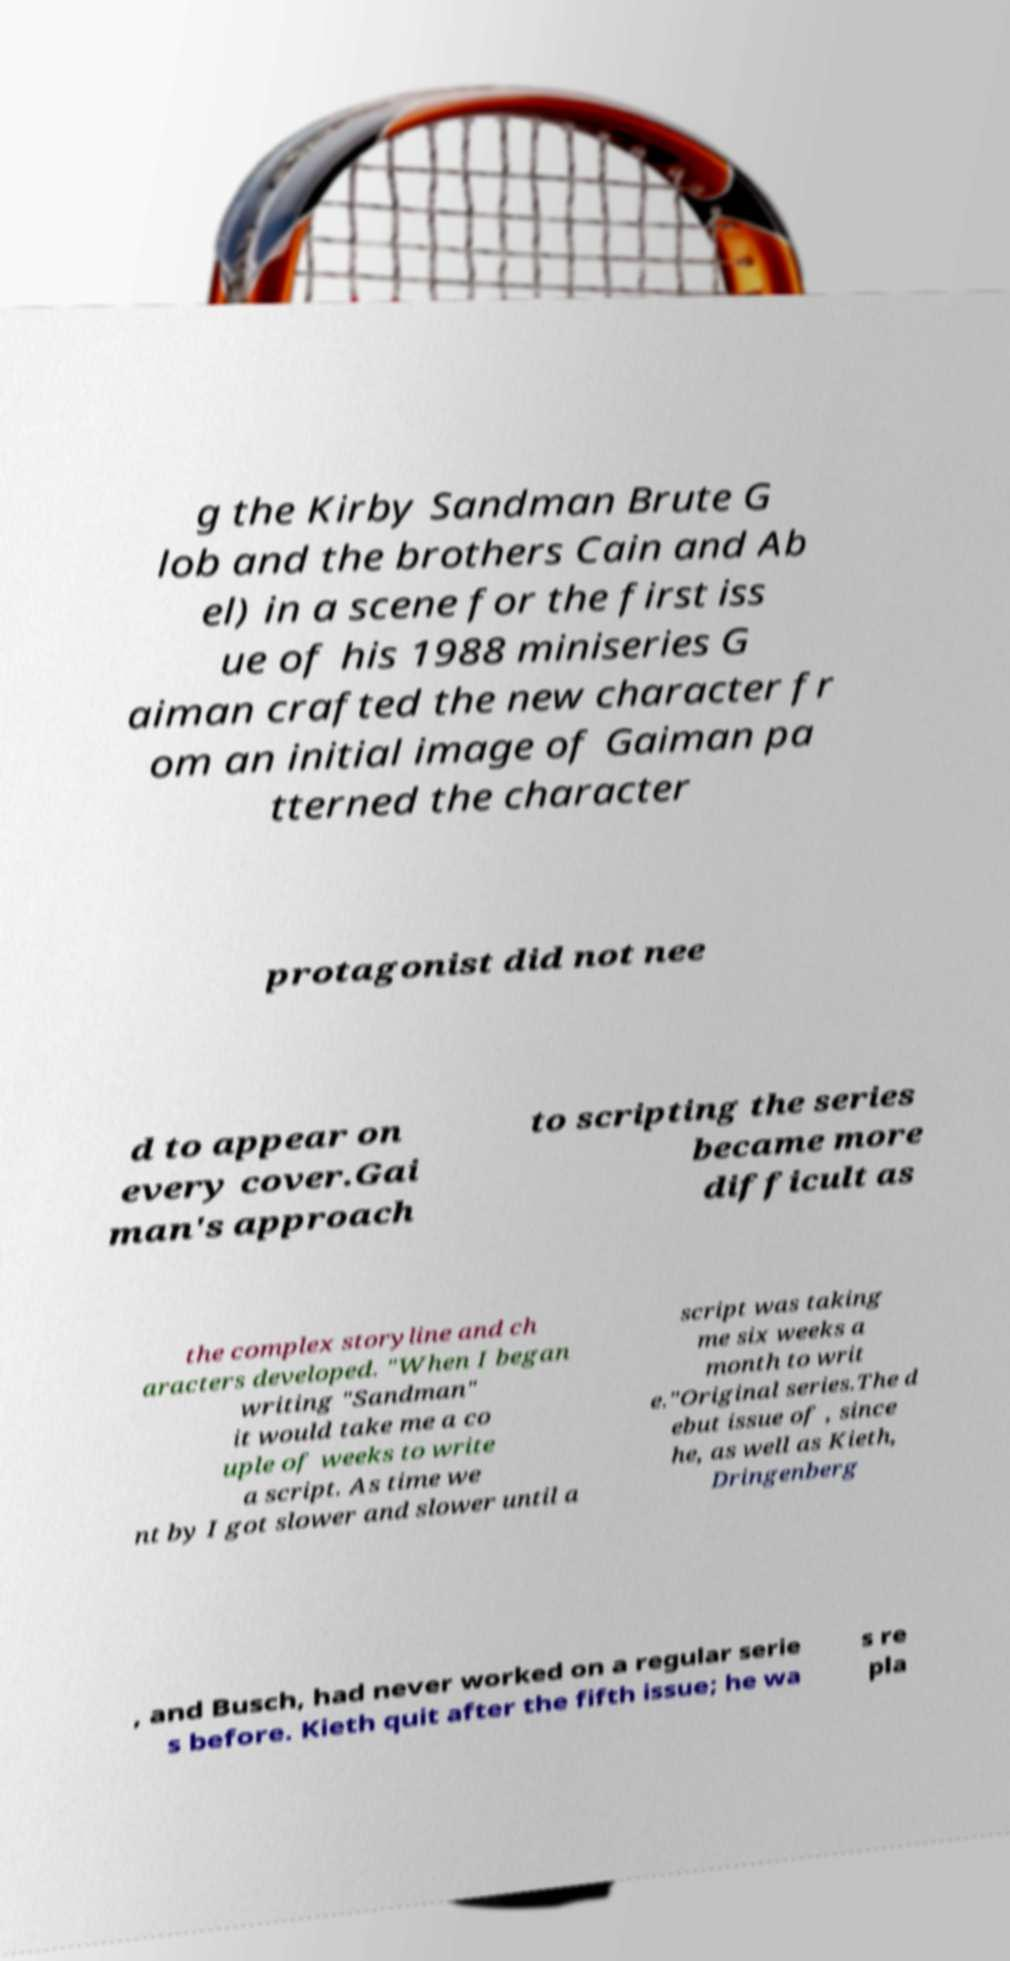For documentation purposes, I need the text within this image transcribed. Could you provide that? g the Kirby Sandman Brute G lob and the brothers Cain and Ab el) in a scene for the first iss ue of his 1988 miniseries G aiman crafted the new character fr om an initial image of Gaiman pa tterned the character protagonist did not nee d to appear on every cover.Gai man's approach to scripting the series became more difficult as the complex storyline and ch aracters developed. "When I began writing "Sandman" it would take me a co uple of weeks to write a script. As time we nt by I got slower and slower until a script was taking me six weeks a month to writ e."Original series.The d ebut issue of , since he, as well as Kieth, Dringenberg , and Busch, had never worked on a regular serie s before. Kieth quit after the fifth issue; he wa s re pla 